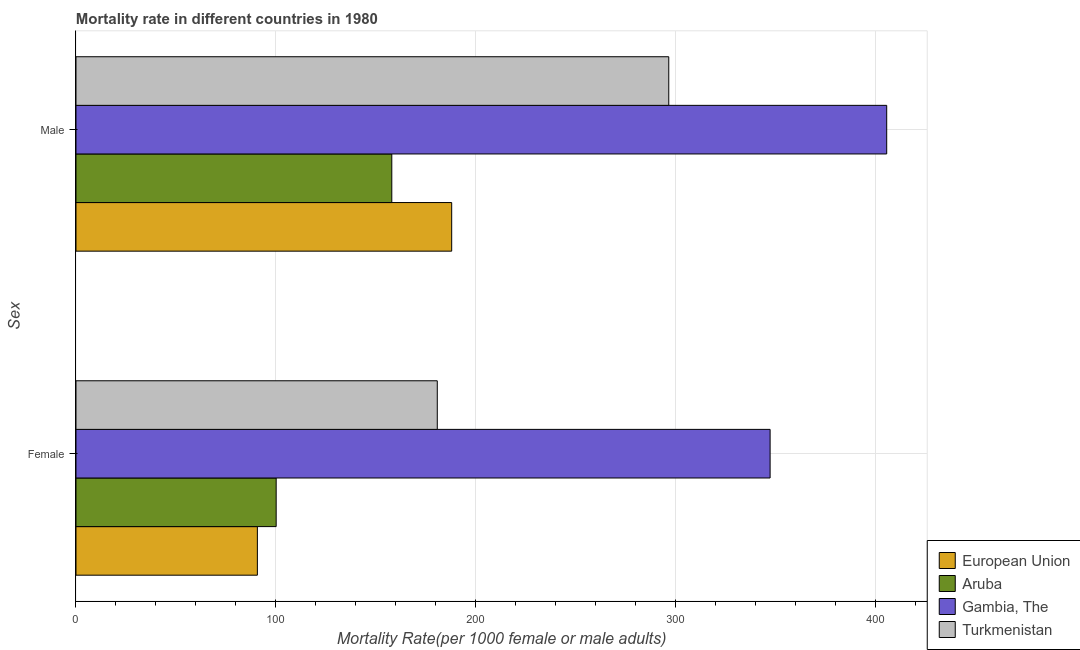How many different coloured bars are there?
Provide a succinct answer. 4. Are the number of bars per tick equal to the number of legend labels?
Provide a succinct answer. Yes. Are the number of bars on each tick of the Y-axis equal?
Give a very brief answer. Yes. What is the male mortality rate in European Union?
Offer a terse response. 188.06. Across all countries, what is the maximum male mortality rate?
Your answer should be compact. 405.8. Across all countries, what is the minimum male mortality rate?
Your response must be concise. 158.07. In which country was the female mortality rate maximum?
Offer a terse response. Gambia, The. In which country was the male mortality rate minimum?
Offer a terse response. Aruba. What is the total female mortality rate in the graph?
Keep it short and to the point. 719.27. What is the difference between the male mortality rate in Turkmenistan and that in European Union?
Ensure brevity in your answer.  108.66. What is the difference between the female mortality rate in Turkmenistan and the male mortality rate in European Union?
Provide a short and direct response. -7.22. What is the average female mortality rate per country?
Offer a very short reply. 179.82. What is the difference between the female mortality rate and male mortality rate in Turkmenistan?
Keep it short and to the point. -115.87. In how many countries, is the female mortality rate greater than 20 ?
Keep it short and to the point. 4. What is the ratio of the female mortality rate in Gambia, The to that in Turkmenistan?
Offer a very short reply. 1.92. Is the male mortality rate in European Union less than that in Aruba?
Offer a very short reply. No. What does the 1st bar from the top in Male represents?
Your answer should be very brief. Turkmenistan. What does the 1st bar from the bottom in Female represents?
Your response must be concise. European Union. Are all the bars in the graph horizontal?
Provide a short and direct response. Yes. What is the difference between two consecutive major ticks on the X-axis?
Offer a terse response. 100. Are the values on the major ticks of X-axis written in scientific E-notation?
Offer a terse response. No. Does the graph contain grids?
Make the answer very short. Yes. Where does the legend appear in the graph?
Your answer should be very brief. Bottom right. How many legend labels are there?
Give a very brief answer. 4. What is the title of the graph?
Give a very brief answer. Mortality rate in different countries in 1980. What is the label or title of the X-axis?
Your answer should be compact. Mortality Rate(per 1000 female or male adults). What is the label or title of the Y-axis?
Provide a short and direct response. Sex. What is the Mortality Rate(per 1000 female or male adults) in European Union in Female?
Provide a succinct answer. 90.79. What is the Mortality Rate(per 1000 female or male adults) of Aruba in Female?
Your response must be concise. 100.2. What is the Mortality Rate(per 1000 female or male adults) of Gambia, The in Female?
Give a very brief answer. 347.44. What is the Mortality Rate(per 1000 female or male adults) of Turkmenistan in Female?
Your answer should be very brief. 180.84. What is the Mortality Rate(per 1000 female or male adults) of European Union in Male?
Provide a succinct answer. 188.06. What is the Mortality Rate(per 1000 female or male adults) in Aruba in Male?
Your answer should be compact. 158.07. What is the Mortality Rate(per 1000 female or male adults) in Gambia, The in Male?
Provide a succinct answer. 405.8. What is the Mortality Rate(per 1000 female or male adults) in Turkmenistan in Male?
Offer a terse response. 296.71. Across all Sex, what is the maximum Mortality Rate(per 1000 female or male adults) of European Union?
Your answer should be compact. 188.06. Across all Sex, what is the maximum Mortality Rate(per 1000 female or male adults) in Aruba?
Ensure brevity in your answer.  158.07. Across all Sex, what is the maximum Mortality Rate(per 1000 female or male adults) of Gambia, The?
Your answer should be very brief. 405.8. Across all Sex, what is the maximum Mortality Rate(per 1000 female or male adults) of Turkmenistan?
Provide a short and direct response. 296.71. Across all Sex, what is the minimum Mortality Rate(per 1000 female or male adults) of European Union?
Ensure brevity in your answer.  90.79. Across all Sex, what is the minimum Mortality Rate(per 1000 female or male adults) of Aruba?
Offer a very short reply. 100.2. Across all Sex, what is the minimum Mortality Rate(per 1000 female or male adults) in Gambia, The?
Provide a short and direct response. 347.44. Across all Sex, what is the minimum Mortality Rate(per 1000 female or male adults) of Turkmenistan?
Your answer should be compact. 180.84. What is the total Mortality Rate(per 1000 female or male adults) of European Union in the graph?
Provide a short and direct response. 278.85. What is the total Mortality Rate(per 1000 female or male adults) of Aruba in the graph?
Your answer should be very brief. 258.27. What is the total Mortality Rate(per 1000 female or male adults) of Gambia, The in the graph?
Provide a succinct answer. 753.24. What is the total Mortality Rate(per 1000 female or male adults) of Turkmenistan in the graph?
Keep it short and to the point. 477.55. What is the difference between the Mortality Rate(per 1000 female or male adults) of European Union in Female and that in Male?
Keep it short and to the point. -97.26. What is the difference between the Mortality Rate(per 1000 female or male adults) of Aruba in Female and that in Male?
Your answer should be compact. -57.88. What is the difference between the Mortality Rate(per 1000 female or male adults) in Gambia, The in Female and that in Male?
Your answer should be compact. -58.36. What is the difference between the Mortality Rate(per 1000 female or male adults) of Turkmenistan in Female and that in Male?
Your answer should be compact. -115.87. What is the difference between the Mortality Rate(per 1000 female or male adults) in European Union in Female and the Mortality Rate(per 1000 female or male adults) in Aruba in Male?
Make the answer very short. -67.28. What is the difference between the Mortality Rate(per 1000 female or male adults) of European Union in Female and the Mortality Rate(per 1000 female or male adults) of Gambia, The in Male?
Keep it short and to the point. -315.01. What is the difference between the Mortality Rate(per 1000 female or male adults) of European Union in Female and the Mortality Rate(per 1000 female or male adults) of Turkmenistan in Male?
Ensure brevity in your answer.  -205.92. What is the difference between the Mortality Rate(per 1000 female or male adults) in Aruba in Female and the Mortality Rate(per 1000 female or male adults) in Gambia, The in Male?
Offer a terse response. -305.6. What is the difference between the Mortality Rate(per 1000 female or male adults) of Aruba in Female and the Mortality Rate(per 1000 female or male adults) of Turkmenistan in Male?
Give a very brief answer. -196.51. What is the difference between the Mortality Rate(per 1000 female or male adults) in Gambia, The in Female and the Mortality Rate(per 1000 female or male adults) in Turkmenistan in Male?
Keep it short and to the point. 50.73. What is the average Mortality Rate(per 1000 female or male adults) of European Union per Sex?
Your answer should be very brief. 139.43. What is the average Mortality Rate(per 1000 female or male adults) of Aruba per Sex?
Offer a very short reply. 129.14. What is the average Mortality Rate(per 1000 female or male adults) in Gambia, The per Sex?
Offer a terse response. 376.62. What is the average Mortality Rate(per 1000 female or male adults) in Turkmenistan per Sex?
Offer a terse response. 238.78. What is the difference between the Mortality Rate(per 1000 female or male adults) of European Union and Mortality Rate(per 1000 female or male adults) of Aruba in Female?
Offer a terse response. -9.4. What is the difference between the Mortality Rate(per 1000 female or male adults) of European Union and Mortality Rate(per 1000 female or male adults) of Gambia, The in Female?
Your answer should be compact. -256.65. What is the difference between the Mortality Rate(per 1000 female or male adults) in European Union and Mortality Rate(per 1000 female or male adults) in Turkmenistan in Female?
Your answer should be compact. -90.05. What is the difference between the Mortality Rate(per 1000 female or male adults) of Aruba and Mortality Rate(per 1000 female or male adults) of Gambia, The in Female?
Ensure brevity in your answer.  -247.24. What is the difference between the Mortality Rate(per 1000 female or male adults) in Aruba and Mortality Rate(per 1000 female or male adults) in Turkmenistan in Female?
Make the answer very short. -80.64. What is the difference between the Mortality Rate(per 1000 female or male adults) in Gambia, The and Mortality Rate(per 1000 female or male adults) in Turkmenistan in Female?
Give a very brief answer. 166.6. What is the difference between the Mortality Rate(per 1000 female or male adults) of European Union and Mortality Rate(per 1000 female or male adults) of Aruba in Male?
Your answer should be compact. 29.98. What is the difference between the Mortality Rate(per 1000 female or male adults) in European Union and Mortality Rate(per 1000 female or male adults) in Gambia, The in Male?
Offer a very short reply. -217.74. What is the difference between the Mortality Rate(per 1000 female or male adults) in European Union and Mortality Rate(per 1000 female or male adults) in Turkmenistan in Male?
Your answer should be compact. -108.66. What is the difference between the Mortality Rate(per 1000 female or male adults) in Aruba and Mortality Rate(per 1000 female or male adults) in Gambia, The in Male?
Provide a short and direct response. -247.73. What is the difference between the Mortality Rate(per 1000 female or male adults) of Aruba and Mortality Rate(per 1000 female or male adults) of Turkmenistan in Male?
Make the answer very short. -138.64. What is the difference between the Mortality Rate(per 1000 female or male adults) in Gambia, The and Mortality Rate(per 1000 female or male adults) in Turkmenistan in Male?
Your answer should be very brief. 109.09. What is the ratio of the Mortality Rate(per 1000 female or male adults) of European Union in Female to that in Male?
Make the answer very short. 0.48. What is the ratio of the Mortality Rate(per 1000 female or male adults) of Aruba in Female to that in Male?
Give a very brief answer. 0.63. What is the ratio of the Mortality Rate(per 1000 female or male adults) in Gambia, The in Female to that in Male?
Your answer should be very brief. 0.86. What is the ratio of the Mortality Rate(per 1000 female or male adults) of Turkmenistan in Female to that in Male?
Offer a terse response. 0.61. What is the difference between the highest and the second highest Mortality Rate(per 1000 female or male adults) of European Union?
Provide a succinct answer. 97.26. What is the difference between the highest and the second highest Mortality Rate(per 1000 female or male adults) in Aruba?
Keep it short and to the point. 57.88. What is the difference between the highest and the second highest Mortality Rate(per 1000 female or male adults) of Gambia, The?
Your response must be concise. 58.36. What is the difference between the highest and the second highest Mortality Rate(per 1000 female or male adults) in Turkmenistan?
Your response must be concise. 115.87. What is the difference between the highest and the lowest Mortality Rate(per 1000 female or male adults) of European Union?
Your response must be concise. 97.26. What is the difference between the highest and the lowest Mortality Rate(per 1000 female or male adults) in Aruba?
Your answer should be very brief. 57.88. What is the difference between the highest and the lowest Mortality Rate(per 1000 female or male adults) of Gambia, The?
Your response must be concise. 58.36. What is the difference between the highest and the lowest Mortality Rate(per 1000 female or male adults) in Turkmenistan?
Offer a very short reply. 115.87. 